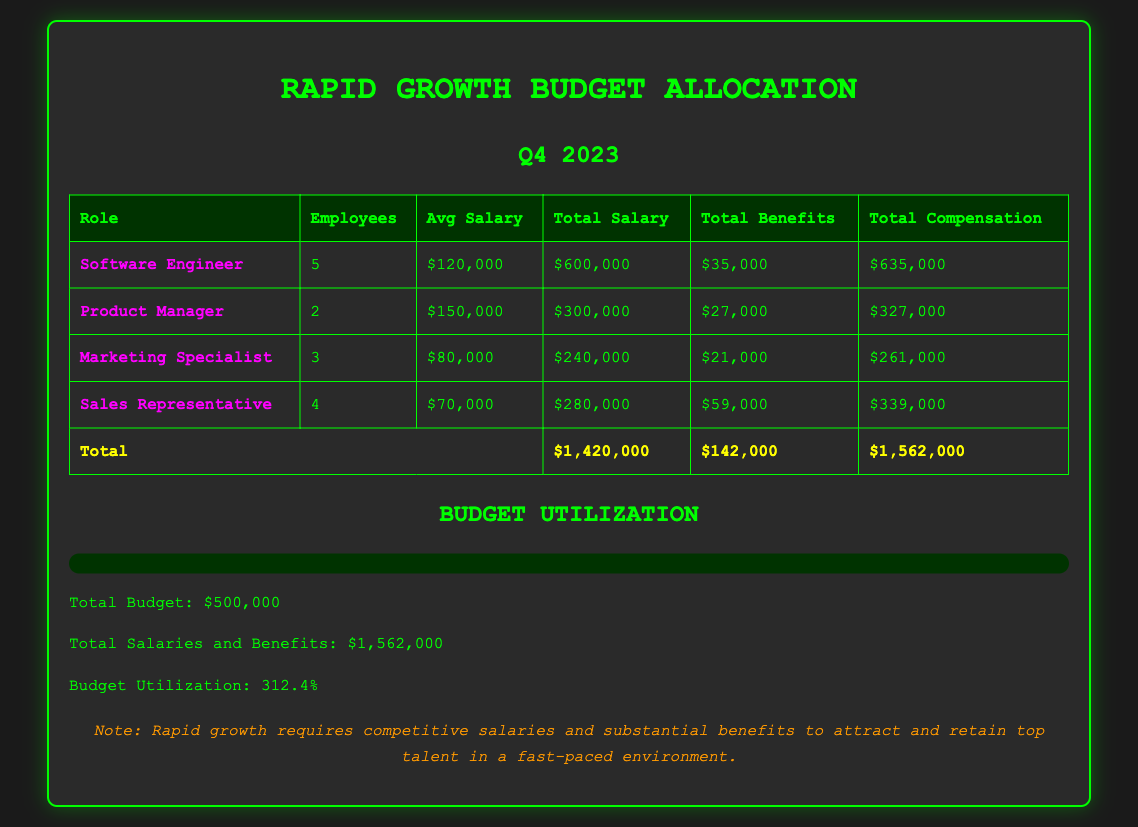What is the average salary of a Software Engineer? The average salary for a Software Engineer, as listed in the document, is $120,000.
Answer: $120,000 How many Marketing Specialists are there? The document specifies that there are 3 Marketing Specialists.
Answer: 3 What is the total compensation for Product Managers? Total compensation for Product Managers is provided in the document as $327,000.
Answer: $327,000 What percentage of the budget is utilized? The document indicates that the budget utilization is 312.4%.
Answer: 312.4% What is the total salary expenditure for all roles? The total salary expenditure is calculated as the sum of all total salaries, which equals $1,420,000.
Answer: $1,420,000 What is the total benefits allocation? The total benefits allocation across all roles is mentioned as $142,000.
Answer: $142,000 Which role has the highest total compensation? The document indicates that the Software Engineer role has the highest total compensation of $635,000.
Answer: Software Engineer What is the total number of employees across all roles? The total number of employees can be calculated by summing all employees in each role, giving a total of 14.
Answer: 14 What is the average salary of a Sales Representative? According to the document, the average salary for a Sales Representative is $70,000.
Answer: $70,000 